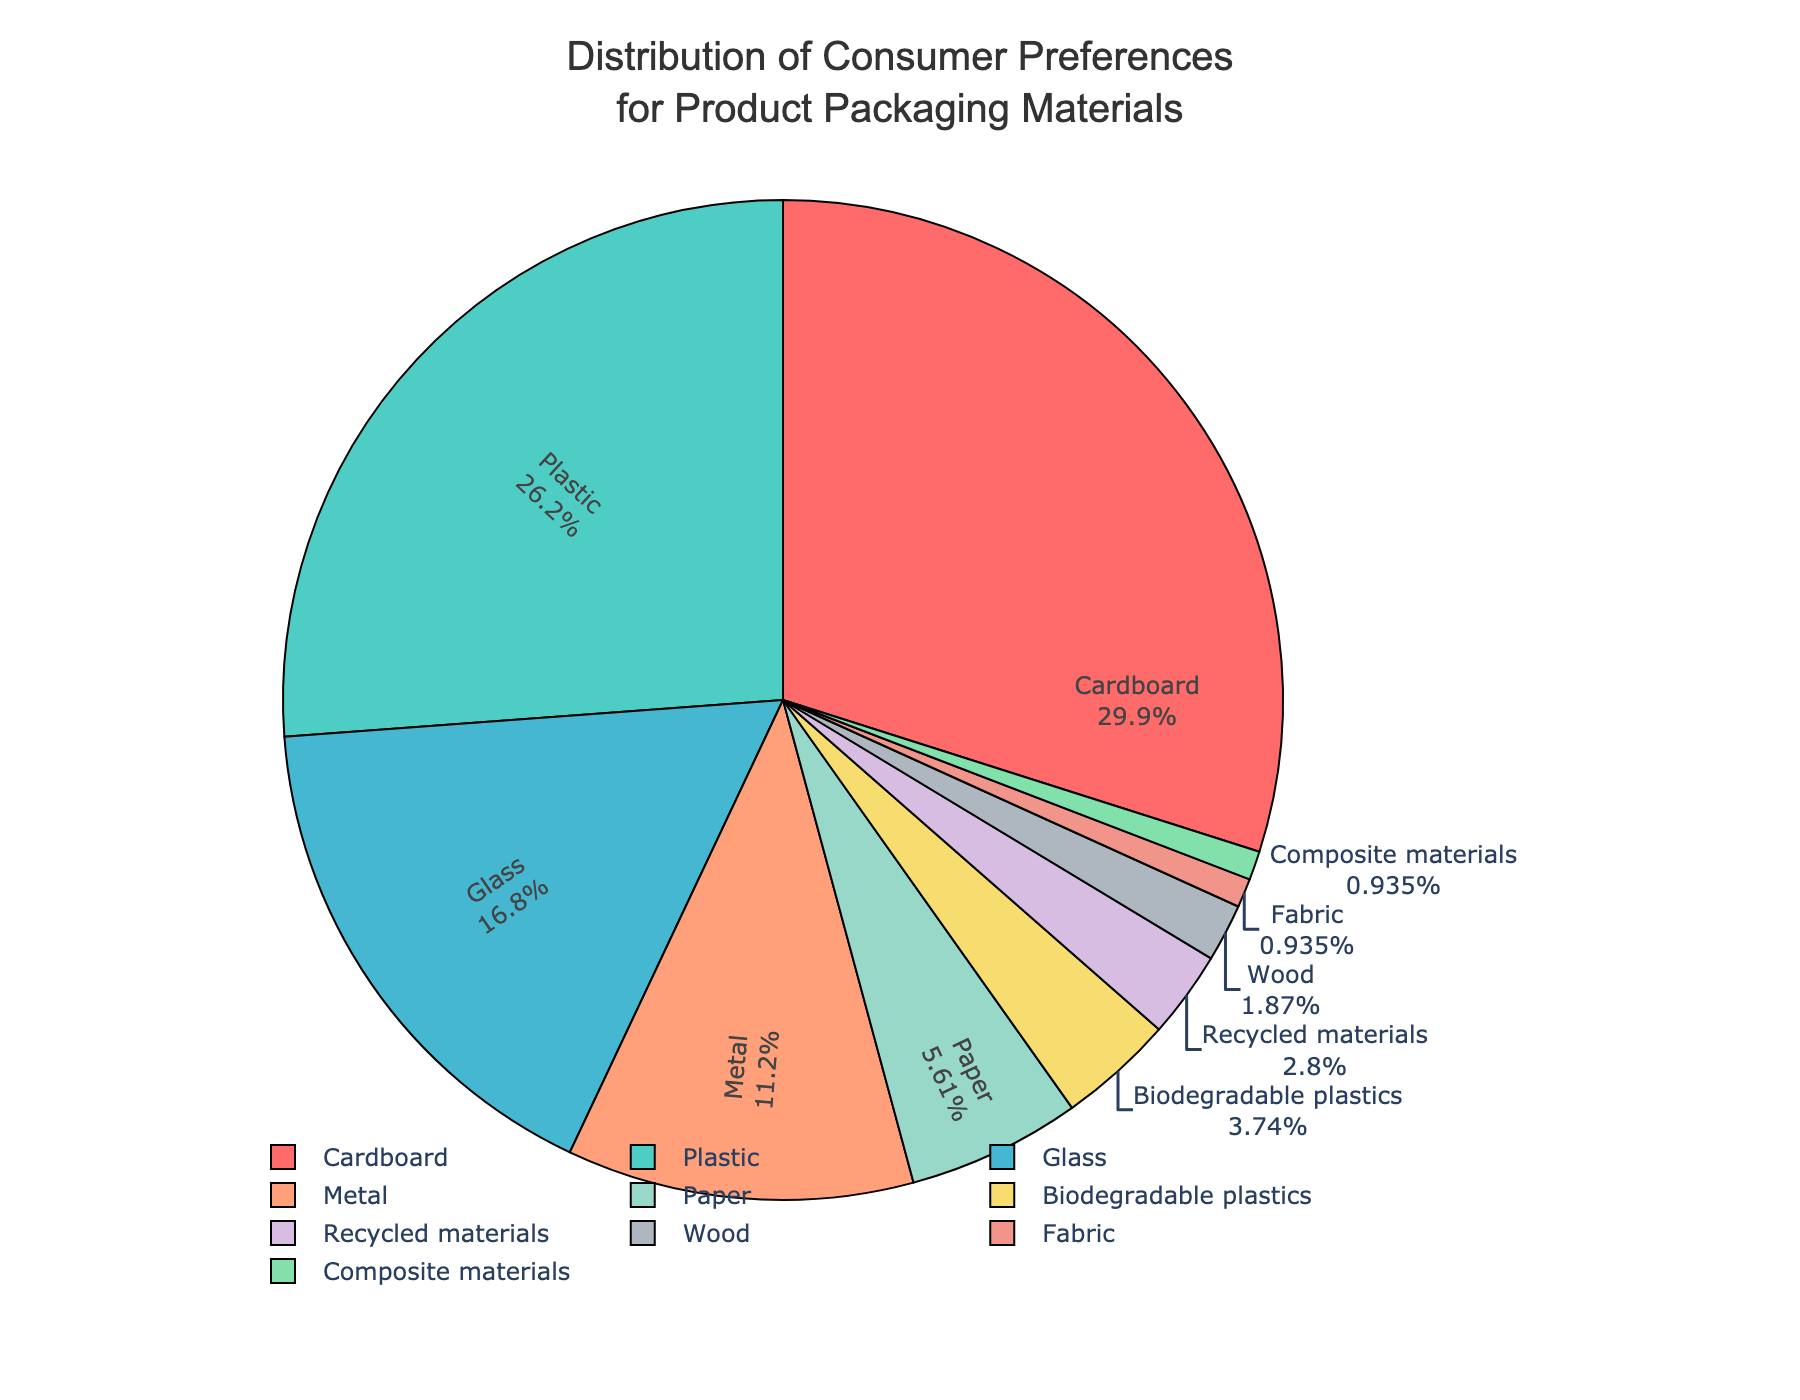What material has the highest consumer preference? The pie chart depicts various packaging materials with their corresponding percentage values. The segment with the highest percentage value corresponds to the material with the highest consumer preference. From the chart, Cardboard has the highest percentage at 32%.
Answer: Cardboard What is the combined preference percentage for Plastic and Glass? The pie chart shows the percentage values for each material. To find the combined preference percentage for Plastic and Glass, add their percentages: Plastic (28%) + Glass (18%) = 46%.
Answer: 46% Which material has a lower preference, Wood or Fabric? The pie chart shows the percentage values for each material. To determine which has a lower preference, compare their percentages. Wood has 2%, while Fabric has 1%. Fabric has a lower preference.
Answer: Fabric What is the difference in preference percentages between Cardboard and Recycled materials? From the chart, find the percentages of Cardboard and Recycled materials, which are 32% and 3% respectively. The difference is calculated as 32% - 3% = 29%.
Answer: 29% How does the preference for Metal compare to that for Paper? The pie chart shows the percentage values for Metal and Paper as 12% and 6% respectively. Since 12% (Metal) is greater than 6% (Paper), Metal has a higher preference than Paper.
Answer: Metal has a higher preference How many materials have a preference percentage lower than 5%? Identify and count the segments with percentage values lower than 5% on the pie chart. The materials with percentages lower than 5% are Biodegradable plastics (4%), Recycled materials (3%), Wood (2%), Fabric (1%), and Composite materials (1%), totaling 5 materials.
Answer: 5 materials If you combine the preferences for all materials at or below 6%, what is their total preference percentage? Find the percentage values for the materials at or below 6% and sum them: Paper (6%), Biodegradable plastics (4%), Recycled materials (3%), Wood (2%), Fabric (1%), Composite materials (1%). The sum is 6% + 4% + 3% + 2% + 1% + 1% = 17%.
Answer: 17% What is the average preference percentage of the top three preferred materials? Identify the top three materials by preference percentages: Cardboard (32%), Plastic (28%), and Glass (18%). Calculate their average: (32% + 28% + 18%) / 3 = 78% / 3 = 26%.
Answer: 26% What percentage is preferred more by consumers: Biodegradable plastics or Recycled materials, and by how much? Compare the percentage values for Biodegradable plastics and Recycled materials. Biodegradable plastics have 4% and Recycled materials have 3%. The difference is 4% - 3% = 1%. Biodegradable plastics are preferred more by 1%.
Answer: Biodegradable plastics by 1% Of the materials that have a preference of 10% or more, what is their total combined percentage? Identify the materials with a preference of 10% or more: Cardboard (32%), Plastic (28%), Glass (18%), and Metal (12%). Sum these values: 32% + 28% + 18% + 12% = 90%.
Answer: 90% 